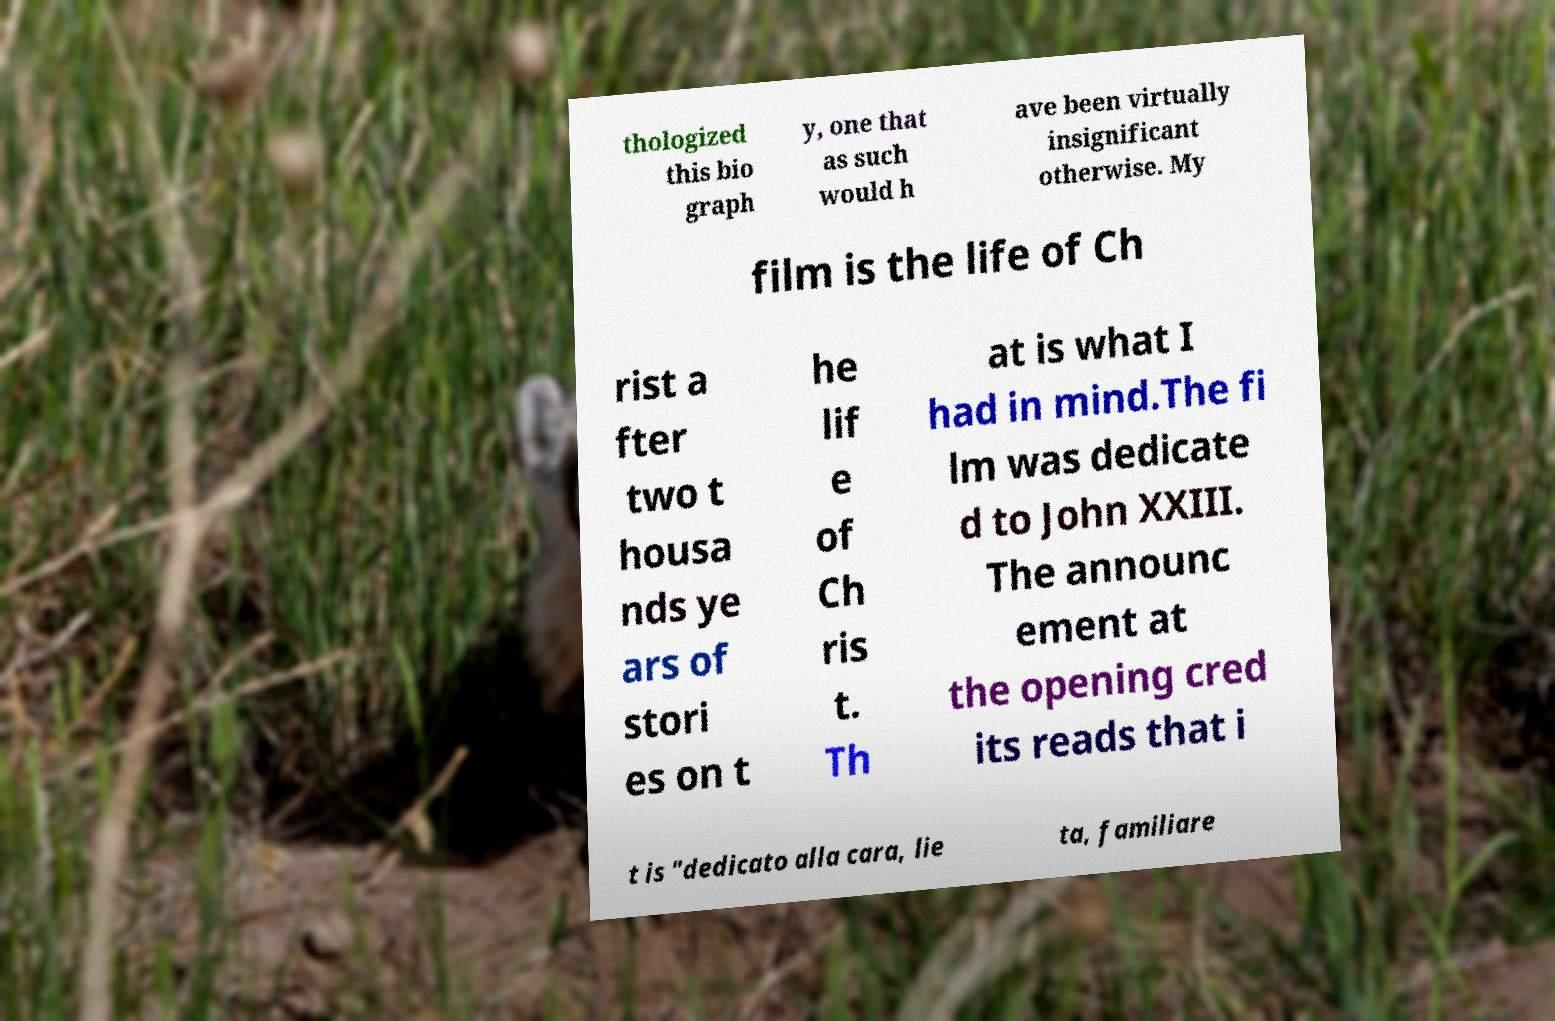Could you assist in decoding the text presented in this image and type it out clearly? thologized this bio graph y, one that as such would h ave been virtually insignificant otherwise. My film is the life of Ch rist a fter two t housa nds ye ars of stori es on t he lif e of Ch ris t. Th at is what I had in mind.The fi lm was dedicate d to John XXIII. The announc ement at the opening cred its reads that i t is "dedicato alla cara, lie ta, familiare 